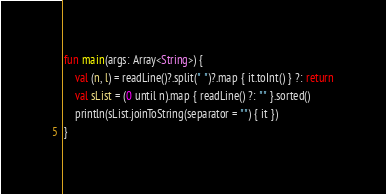Convert code to text. <code><loc_0><loc_0><loc_500><loc_500><_Kotlin_>fun main(args: Array<String>) {
    val (n, l) = readLine()?.split(" ")?.map { it.toInt() } ?: return
    val sList = (0 until n).map { readLine() ?: "" }.sorted()
    println(sList.joinToString(separator = "") { it })
}</code> 